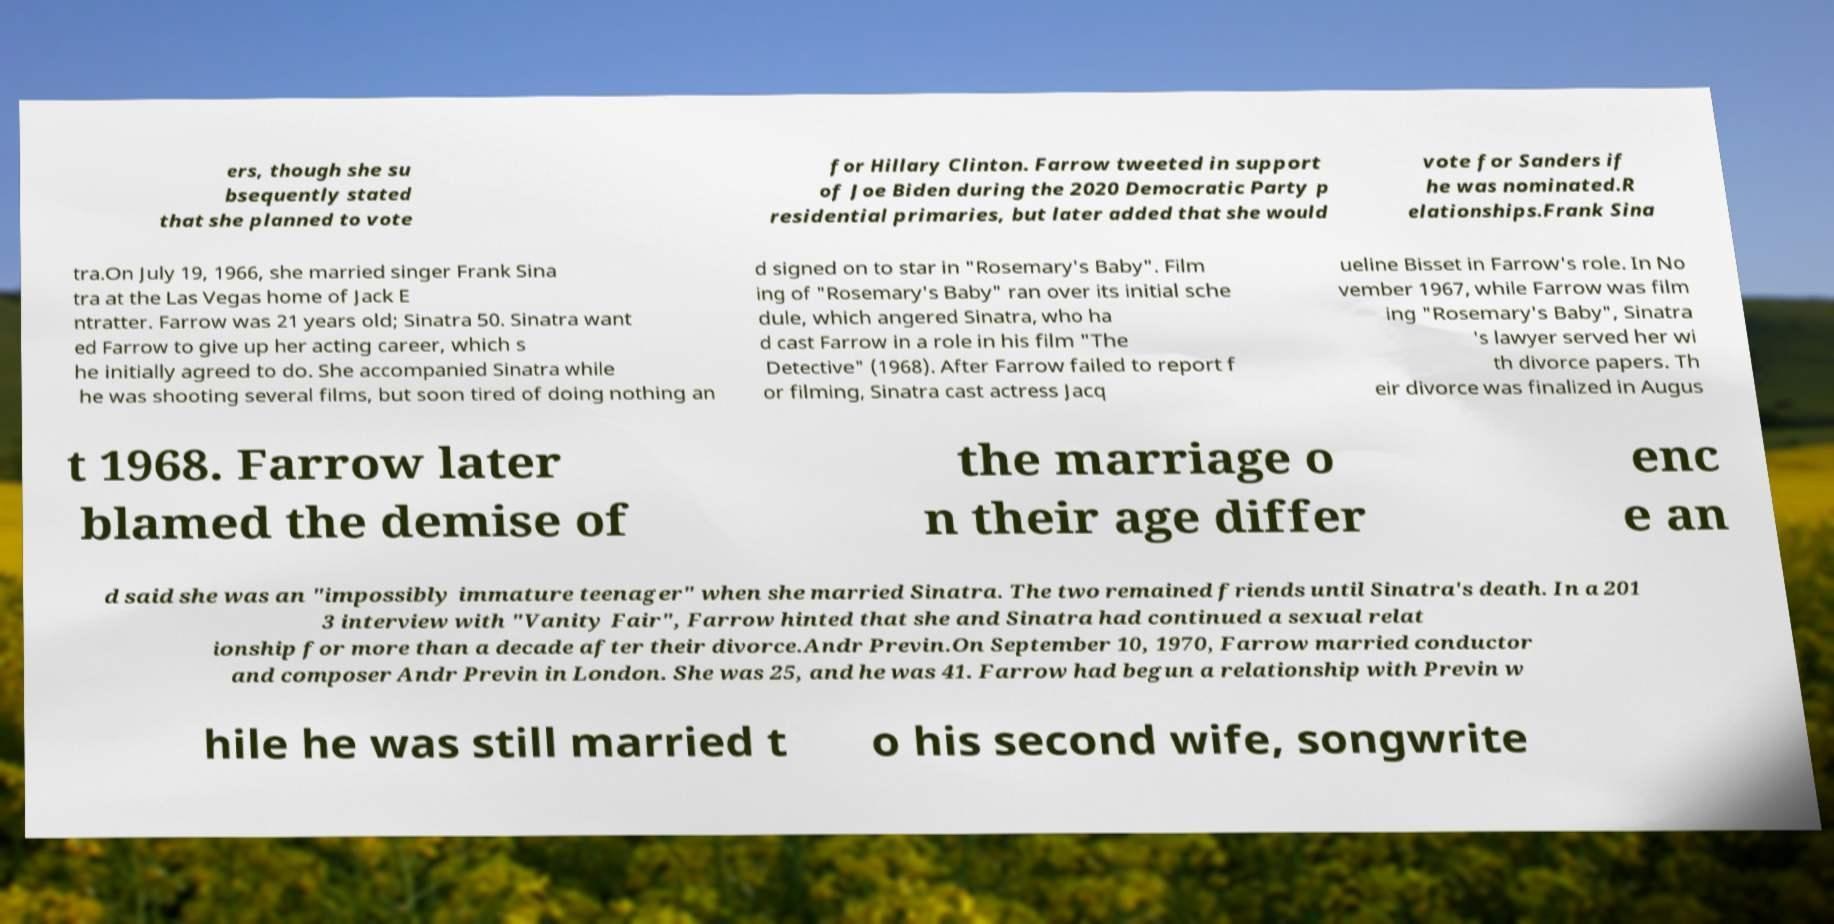Could you assist in decoding the text presented in this image and type it out clearly? ers, though she su bsequently stated that she planned to vote for Hillary Clinton. Farrow tweeted in support of Joe Biden during the 2020 Democratic Party p residential primaries, but later added that she would vote for Sanders if he was nominated.R elationships.Frank Sina tra.On July 19, 1966, she married singer Frank Sina tra at the Las Vegas home of Jack E ntratter. Farrow was 21 years old; Sinatra 50. Sinatra want ed Farrow to give up her acting career, which s he initially agreed to do. She accompanied Sinatra while he was shooting several films, but soon tired of doing nothing an d signed on to star in "Rosemary's Baby". Film ing of "Rosemary's Baby" ran over its initial sche dule, which angered Sinatra, who ha d cast Farrow in a role in his film "The Detective" (1968). After Farrow failed to report f or filming, Sinatra cast actress Jacq ueline Bisset in Farrow's role. In No vember 1967, while Farrow was film ing "Rosemary's Baby", Sinatra 's lawyer served her wi th divorce papers. Th eir divorce was finalized in Augus t 1968. Farrow later blamed the demise of the marriage o n their age differ enc e an d said she was an "impossibly immature teenager" when she married Sinatra. The two remained friends until Sinatra's death. In a 201 3 interview with "Vanity Fair", Farrow hinted that she and Sinatra had continued a sexual relat ionship for more than a decade after their divorce.Andr Previn.On September 10, 1970, Farrow married conductor and composer Andr Previn in London. She was 25, and he was 41. Farrow had begun a relationship with Previn w hile he was still married t o his second wife, songwrite 